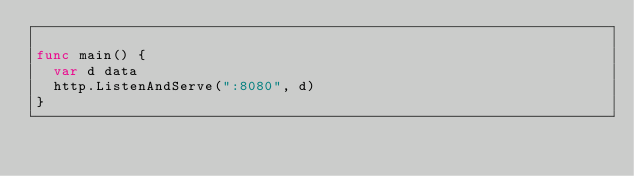<code> <loc_0><loc_0><loc_500><loc_500><_Go_>
func main() {
	var d data
	http.ListenAndServe(":8080", d)
}
</code> 